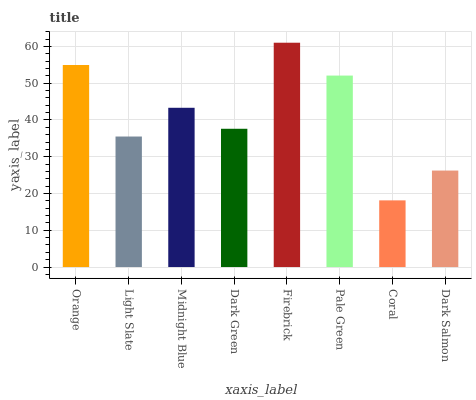Is Coral the minimum?
Answer yes or no. Yes. Is Firebrick the maximum?
Answer yes or no. Yes. Is Light Slate the minimum?
Answer yes or no. No. Is Light Slate the maximum?
Answer yes or no. No. Is Orange greater than Light Slate?
Answer yes or no. Yes. Is Light Slate less than Orange?
Answer yes or no. Yes. Is Light Slate greater than Orange?
Answer yes or no. No. Is Orange less than Light Slate?
Answer yes or no. No. Is Midnight Blue the high median?
Answer yes or no. Yes. Is Dark Green the low median?
Answer yes or no. Yes. Is Pale Green the high median?
Answer yes or no. No. Is Pale Green the low median?
Answer yes or no. No. 